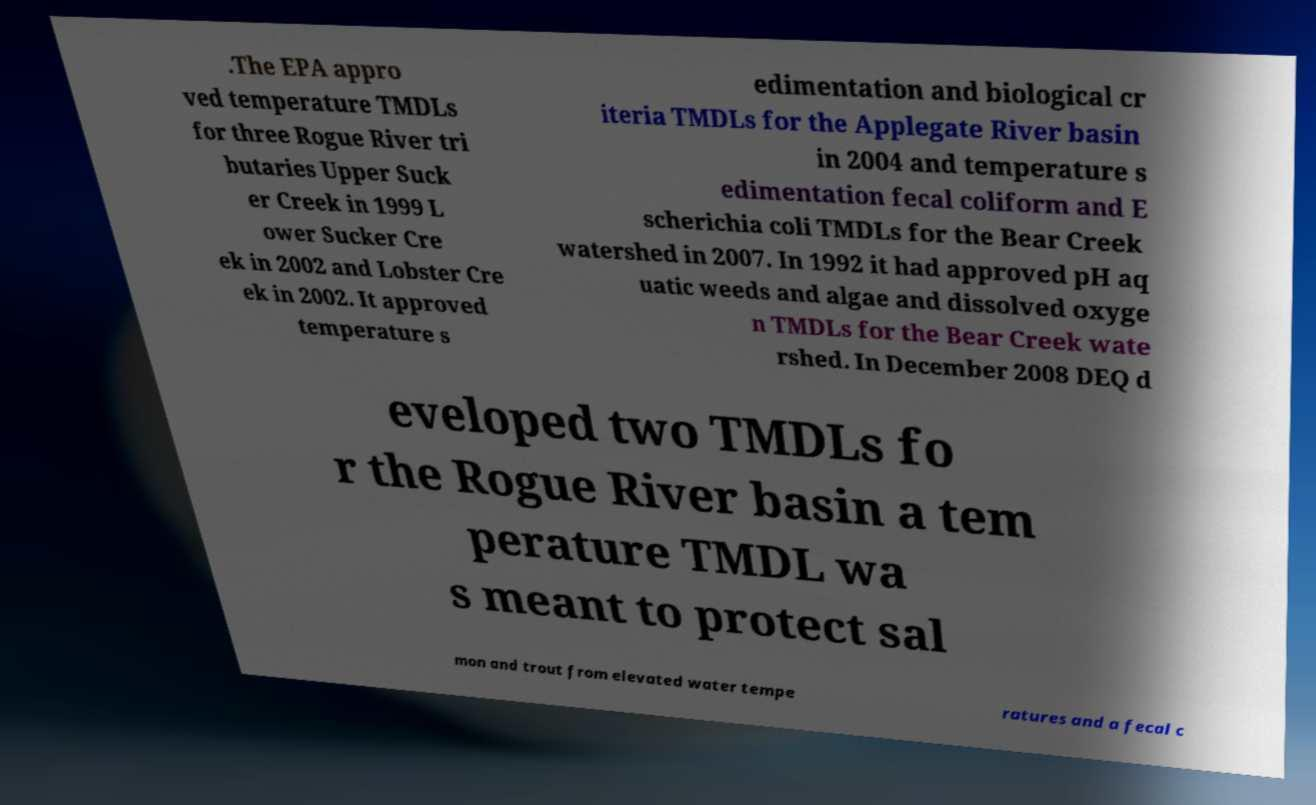For documentation purposes, I need the text within this image transcribed. Could you provide that? .The EPA appro ved temperature TMDLs for three Rogue River tri butaries Upper Suck er Creek in 1999 L ower Sucker Cre ek in 2002 and Lobster Cre ek in 2002. It approved temperature s edimentation and biological cr iteria TMDLs for the Applegate River basin in 2004 and temperature s edimentation fecal coliform and E scherichia coli TMDLs for the Bear Creek watershed in 2007. In 1992 it had approved pH aq uatic weeds and algae and dissolved oxyge n TMDLs for the Bear Creek wate rshed. In December 2008 DEQ d eveloped two TMDLs fo r the Rogue River basin a tem perature TMDL wa s meant to protect sal mon and trout from elevated water tempe ratures and a fecal c 